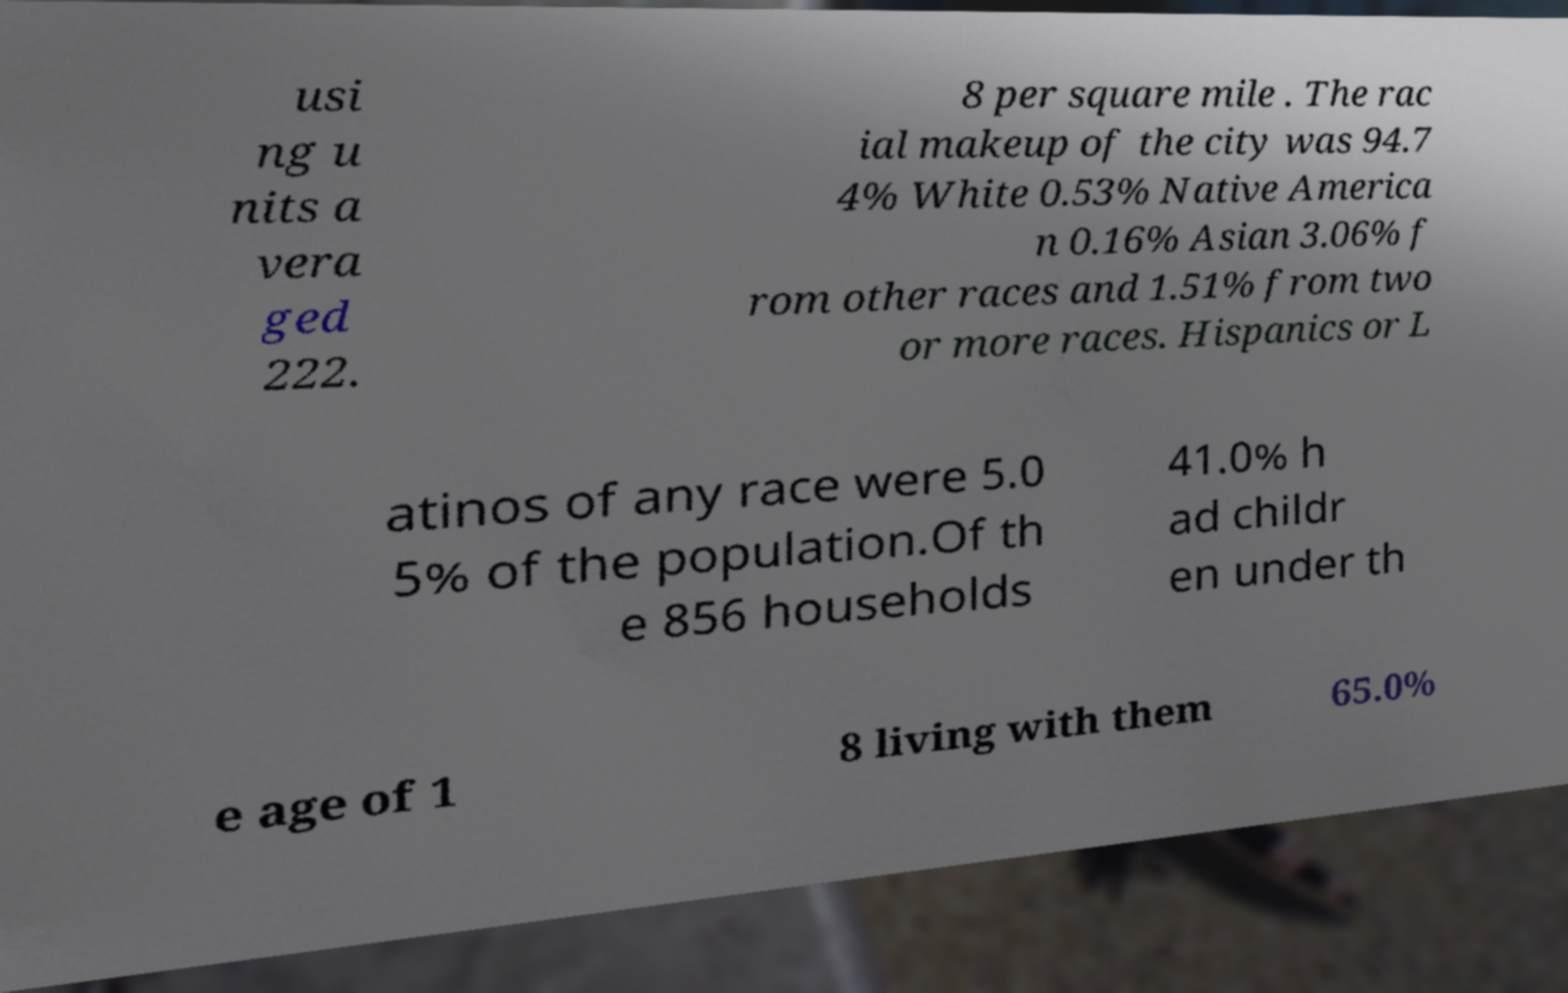I need the written content from this picture converted into text. Can you do that? usi ng u nits a vera ged 222. 8 per square mile . The rac ial makeup of the city was 94.7 4% White 0.53% Native America n 0.16% Asian 3.06% f rom other races and 1.51% from two or more races. Hispanics or L atinos of any race were 5.0 5% of the population.Of th e 856 households 41.0% h ad childr en under th e age of 1 8 living with them 65.0% 